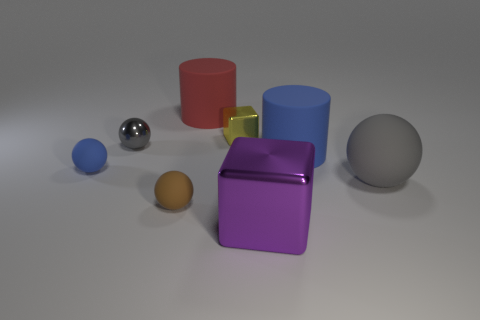Are the tiny yellow cube and the gray sphere that is to the right of the yellow cube made of the same material?
Keep it short and to the point. No. The matte thing that is on the left side of the blue cylinder and behind the small blue rubber thing has what shape?
Keep it short and to the point. Cylinder. What number of other things are the same color as the big cube?
Ensure brevity in your answer.  0. The tiny yellow thing is what shape?
Keep it short and to the point. Cube. What is the color of the tiny metal object on the right side of the small metal thing that is on the left side of the red thing?
Provide a succinct answer. Yellow. Do the small shiny ball and the matte ball on the right side of the large red object have the same color?
Keep it short and to the point. Yes. What is the material of the thing that is both behind the large gray ball and in front of the big blue matte cylinder?
Give a very brief answer. Rubber. Are there any green cylinders of the same size as the red rubber thing?
Your answer should be compact. No. There is a gray thing that is the same size as the yellow metal object; what material is it?
Keep it short and to the point. Metal. There is a small brown thing; how many large cubes are left of it?
Keep it short and to the point. 0. 